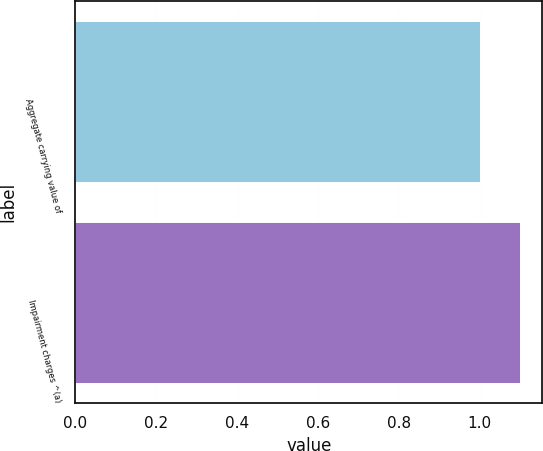<chart> <loc_0><loc_0><loc_500><loc_500><bar_chart><fcel>Aggregate carrying value of<fcel>Impairment charges ^(a)<nl><fcel>1<fcel>1.1<nl></chart> 